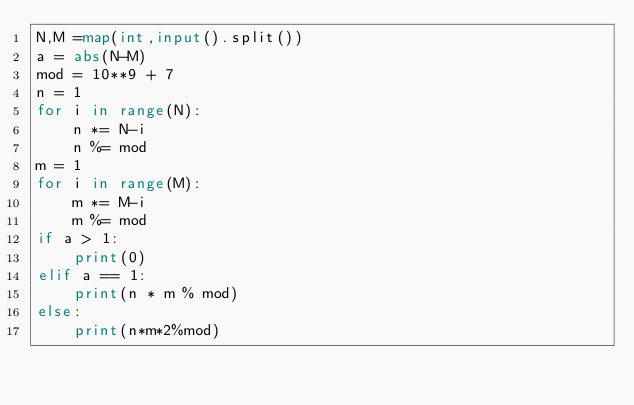<code> <loc_0><loc_0><loc_500><loc_500><_Python_>N,M =map(int,input().split())
a = abs(N-M)
mod = 10**9 + 7
n = 1
for i in range(N):
    n *= N-i
    n %= mod
m = 1
for i in range(M):
    m *= M-i
    m %= mod
if a > 1:
    print(0)
elif a == 1:
    print(n * m % mod)
else:
    print(n*m*2%mod)</code> 